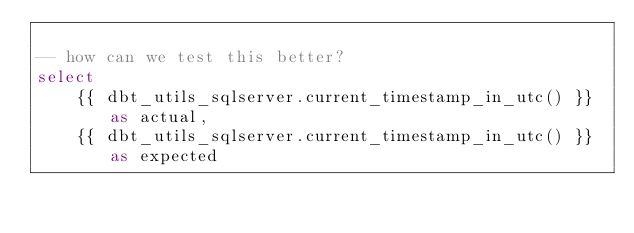Convert code to text. <code><loc_0><loc_0><loc_500><loc_500><_SQL_>
-- how can we test this better?
select
    {{ dbt_utils_sqlserver.current_timestamp_in_utc() }} as actual,
    {{ dbt_utils_sqlserver.current_timestamp_in_utc() }} as expected</code> 